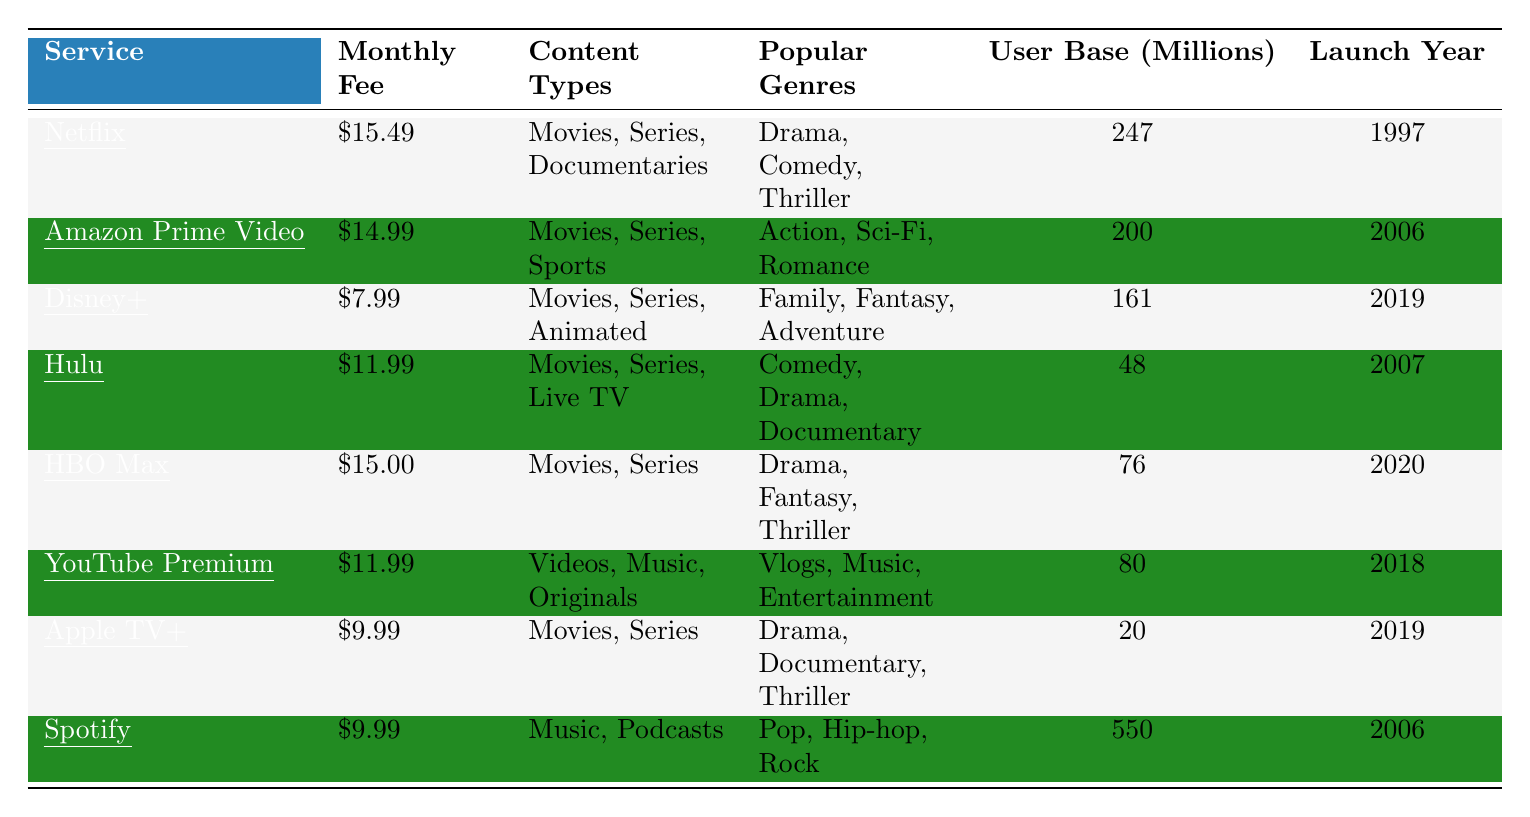What is the monthly fee for Disney+? The table lists the monthly fee for each service. For Disney+, the information shows a monthly fee of $7.99.
Answer: $7.99 Which streaming service has the largest user base? By looking at the user base data in the table, Spotify has the largest user base at 550 million users.
Answer: Spotify What types of content does HBO Max offer? The table details what content types each service provides. HBO Max offers Movies and Series.
Answer: Movies, Series Is the monthly fee for Amazon Prime Video lower than that of Netflix? Comparing the fees for Amazon Prime Video ($14.99) and Netflix ($15.49), Amazon Prime Video's fee is indeed lower.
Answer: Yes What is the average monthly fee of the services listed? To calculate the average, add all the monthly fees: ($15.49 + $14.99 + $7.99 + $11.99 + $15.00 + $11.99 + $9.99 + $9.99) = $100.43. Then, divide by the number of services (8), which gives $100.43 / 8 = $12.55.
Answer: $12.55 Which service launched most recently? The table shows launch years for each service. Disney+ launched in 2019, which is the most recent compared to others.
Answer: Disney+ How many services have a user base of over 100 million? By examining the user base data, Netflix (247 million), Amazon Prime Video (200 million), and Disney+ (161 million) have user bases over 100 million. That totals to three services.
Answer: 3 What genres are popular on Hulu? Looking at the table, Hulu features popular genres that include Comedy, Drama, and Documentary.
Answer: Comedy, Drama, Documentary If you sum the user bases of Netflix and Hulu, what is the total? The user base for Netflix is 247 million and Hulu is 48 million. Thus, 247 + 48 = 295 million.
Answer: 295 million Is Spotify the only service listed that offers Podcasts? A review of the table shows that Spotify offers Podcasts, while no other service mentions this content type.
Answer: Yes 